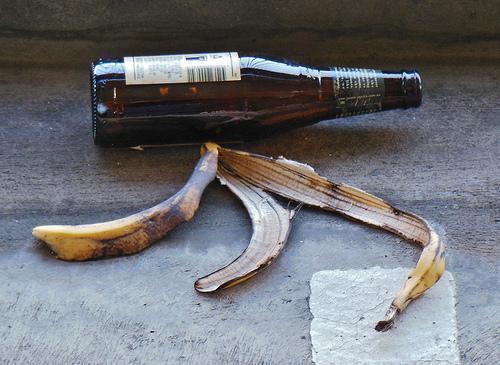How many bottles are there?
Give a very brief answer. 1. 